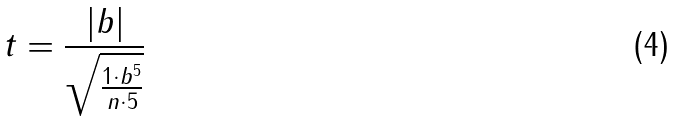Convert formula to latex. <formula><loc_0><loc_0><loc_500><loc_500>t = \frac { | b | } { \sqrt { \frac { 1 \cdot b ^ { 5 } } { n \cdot 5 } } }</formula> 